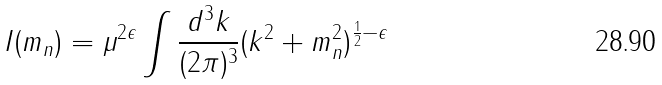<formula> <loc_0><loc_0><loc_500><loc_500>I ( m _ { n } ) = \mu ^ { 2 \epsilon } \int \frac { d ^ { 3 } k } { ( 2 \pi ) ^ { 3 } } ( { k ^ { 2 } + m _ { n } ^ { 2 } } ) ^ { \frac { 1 } { 2 } - \epsilon }</formula> 